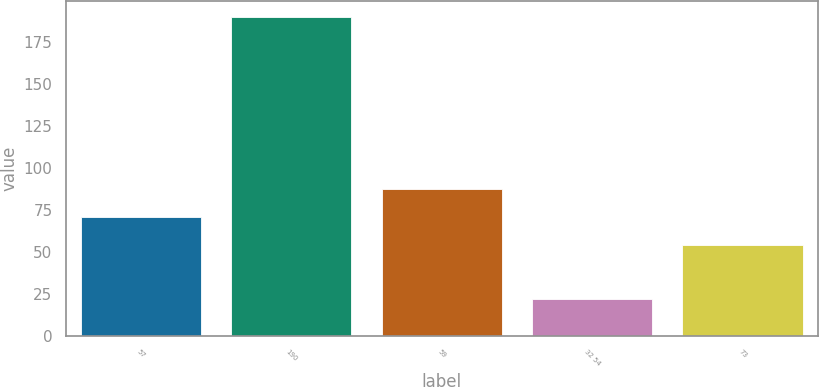Convert chart to OTSL. <chart><loc_0><loc_0><loc_500><loc_500><bar_chart><fcel>57<fcel>190<fcel>59<fcel>32 54<fcel>73<nl><fcel>70.8<fcel>190<fcel>87.6<fcel>22<fcel>54<nl></chart> 